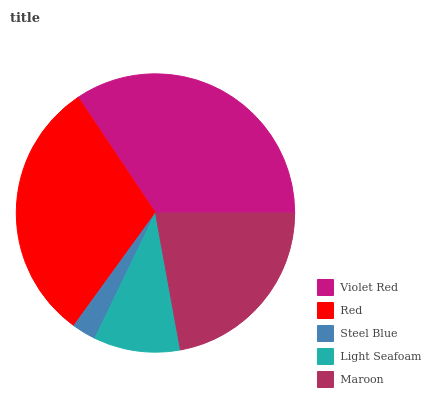Is Steel Blue the minimum?
Answer yes or no. Yes. Is Violet Red the maximum?
Answer yes or no. Yes. Is Red the minimum?
Answer yes or no. No. Is Red the maximum?
Answer yes or no. No. Is Violet Red greater than Red?
Answer yes or no. Yes. Is Red less than Violet Red?
Answer yes or no. Yes. Is Red greater than Violet Red?
Answer yes or no. No. Is Violet Red less than Red?
Answer yes or no. No. Is Maroon the high median?
Answer yes or no. Yes. Is Maroon the low median?
Answer yes or no. Yes. Is Violet Red the high median?
Answer yes or no. No. Is Light Seafoam the low median?
Answer yes or no. No. 